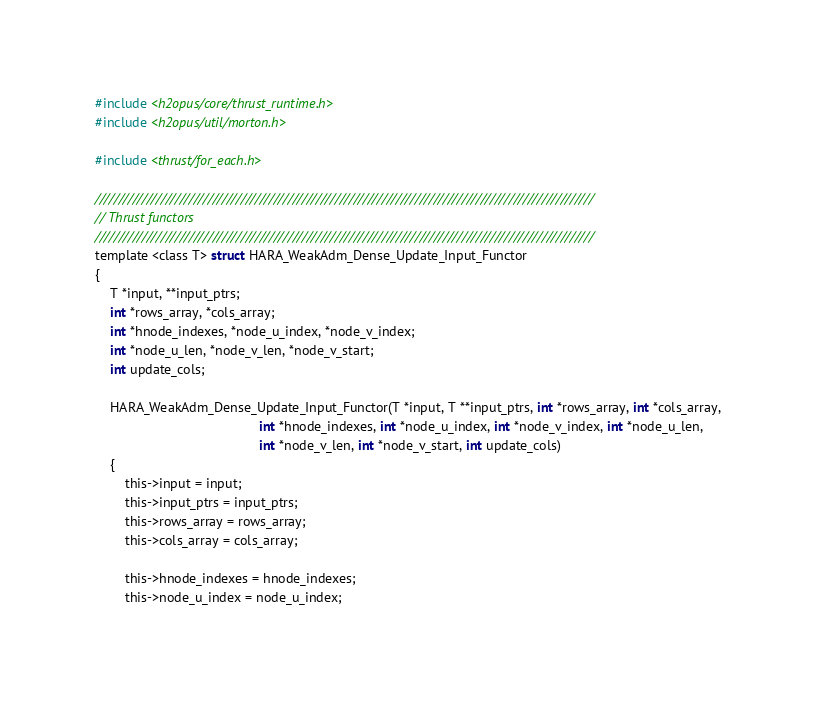<code> <loc_0><loc_0><loc_500><loc_500><_Cuda_>#include <h2opus/core/thrust_runtime.h>
#include <h2opus/util/morton.h>

#include <thrust/for_each.h>

//////////////////////////////////////////////////////////////////////////////////////////////////////////
// Thrust functors
//////////////////////////////////////////////////////////////////////////////////////////////////////////
template <class T> struct HARA_WeakAdm_Dense_Update_Input_Functor
{
    T *input, **input_ptrs;
    int *rows_array, *cols_array;
    int *hnode_indexes, *node_u_index, *node_v_index;
    int *node_u_len, *node_v_len, *node_v_start;
    int update_cols;

    HARA_WeakAdm_Dense_Update_Input_Functor(T *input, T **input_ptrs, int *rows_array, int *cols_array,
                                            int *hnode_indexes, int *node_u_index, int *node_v_index, int *node_u_len,
                                            int *node_v_len, int *node_v_start, int update_cols)
    {
        this->input = input;
        this->input_ptrs = input_ptrs;
        this->rows_array = rows_array;
        this->cols_array = cols_array;

        this->hnode_indexes = hnode_indexes;
        this->node_u_index = node_u_index;</code> 